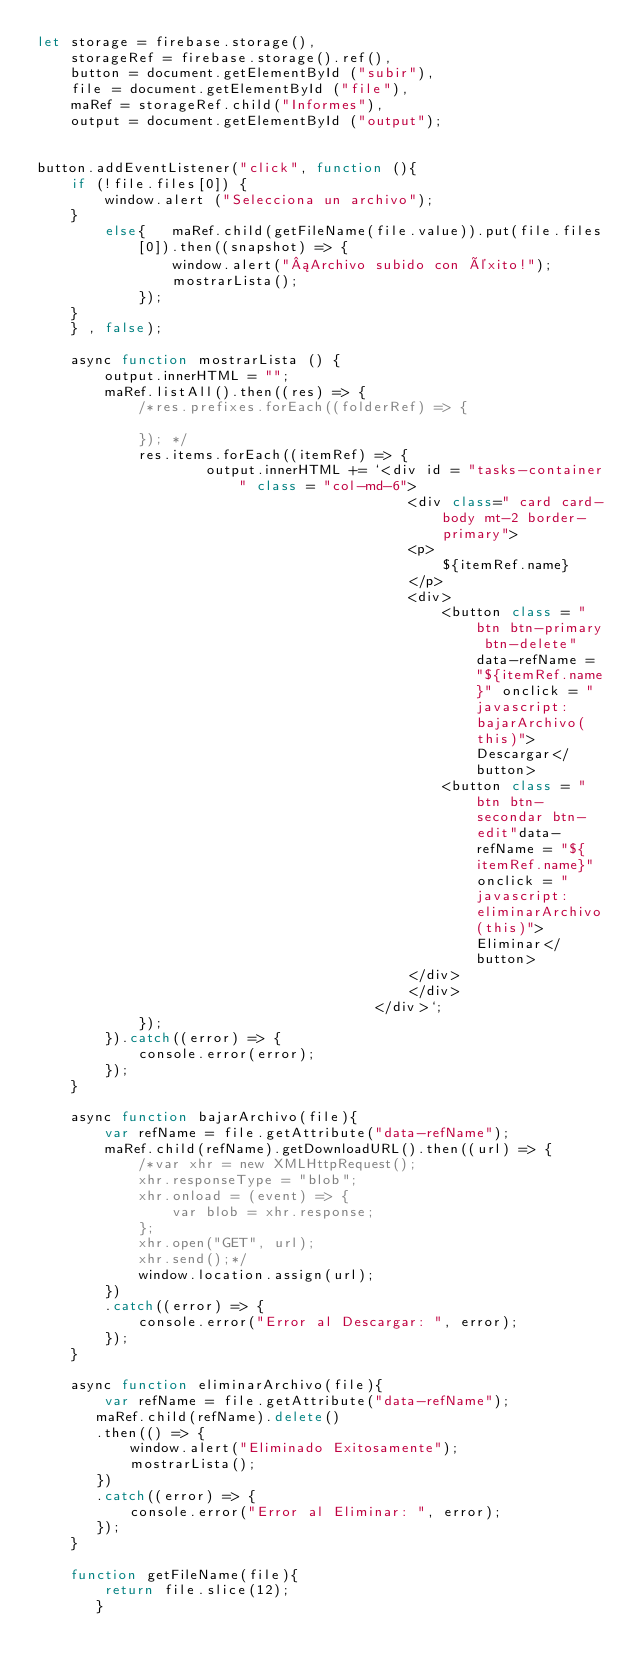Convert code to text. <code><loc_0><loc_0><loc_500><loc_500><_JavaScript_>let storage = firebase.storage(),
    storageRef = firebase.storage().ref(),
    button = document.getElementById ("subir"), 
    file = document.getElementById ("file"),
    maRef = storageRef.child("Informes"),
    output = document.getElementById ("output");


button.addEventListener("click", function (){
    if (!file.files[0]) {
        window.alert ("Selecciona un archivo");
    }
        else{   maRef.child(getFileName(file.value)).put(file.files[0]).then((snapshot) => {
                window.alert("¡Archivo subido con éxito!");
                mostrarLista();
            });
    }
    } , false);

    async function mostrarLista () {
        output.innerHTML = "";
        maRef.listAll().then((res) => {
            /*res.prefixes.forEach((folderRef) => {

            }); */
            res.items.forEach((itemRef) => {
                    output.innerHTML += `<div id = "tasks-container" class = "col-md-6">
                                            <div class=" card card-body mt-2 border-primary">
                                            <p>
                                                ${itemRef.name} 
                                            </p>
                                            <div>
                                                <button class = "btn btn-primary btn-delete" data-refName = "${itemRef.name}" onclick = "javascript:bajarArchivo(this)">Descargar</button>
                                                <button class = "btn btn-secondar btn-edit"data-refName = "${itemRef.name}" onclick = "javascript:eliminarArchivo(this)">Eliminar</button>
                                            </div>
                                            </div>
                                        </div>`;
            });
        }).catch((error) => {
            console.error(error);
        });
    }

    async function bajarArchivo(file){
        var refName = file.getAttribute("data-refName");
        maRef.child(refName).getDownloadURL().then((url) => {
            /*var xhr = new XMLHttpRequest();
            xhr.responseType = "blob";
            xhr.onload = (event) => {
                var blob = xhr.response;
            };
            xhr.open("GET", url);
            xhr.send();*/
            window.location.assign(url);
        })
        .catch((error) => {
            console.error("Error al Descargar: ", error);
        });
    }

    async function eliminarArchivo(file){
        var refName = file.getAttribute("data-refName");
       maRef.child(refName).delete()
       .then(() => {
           window.alert("Eliminado Exitosamente");
           mostrarLista();
       })
       .catch((error) => {
           console.error("Error al Eliminar: ", error);
       });
    }

    function getFileName(file){
        return file.slice(12);
       }</code> 